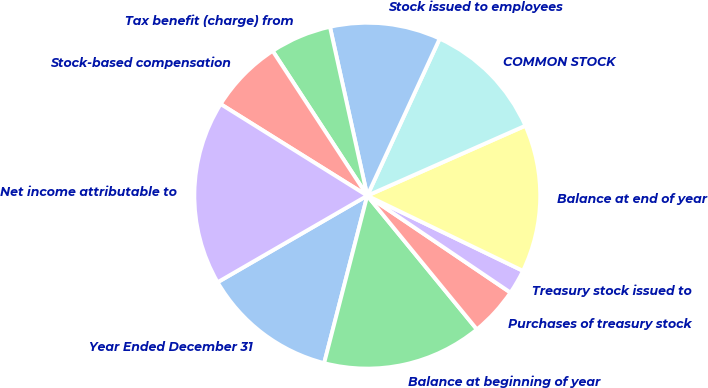<chart> <loc_0><loc_0><loc_500><loc_500><pie_chart><fcel>Year Ended December 31<fcel>Balance at beginning of year<fcel>Purchases of treasury stock<fcel>Treasury stock issued to<fcel>Balance at end of year<fcel>COMMON STOCK<fcel>Stock issued to employees<fcel>Tax benefit (charge) from<fcel>Stock-based compensation<fcel>Net income attributable to<nl><fcel>12.64%<fcel>14.94%<fcel>4.6%<fcel>2.31%<fcel>13.79%<fcel>11.49%<fcel>10.34%<fcel>5.75%<fcel>6.9%<fcel>17.23%<nl></chart> 